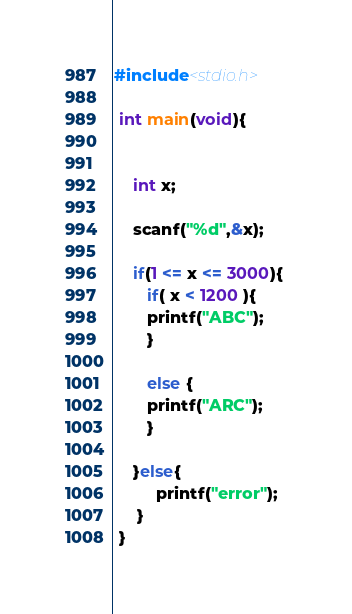Convert code to text. <code><loc_0><loc_0><loc_500><loc_500><_C_>#include<stdio.h>

 int main(void){
 

    int x;

    scanf("%d",&x);
 
    if(1 <= x <= 3000){
       if( x < 1200 ){
       printf("ABC");     
       }
   
       else {
       printf("ARC");
       }
     
    }else{
         printf("error");
     }
 }</code> 